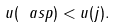Convert formula to latex. <formula><loc_0><loc_0><loc_500><loc_500>u ( \ a s p ) < u ( j ) .</formula> 